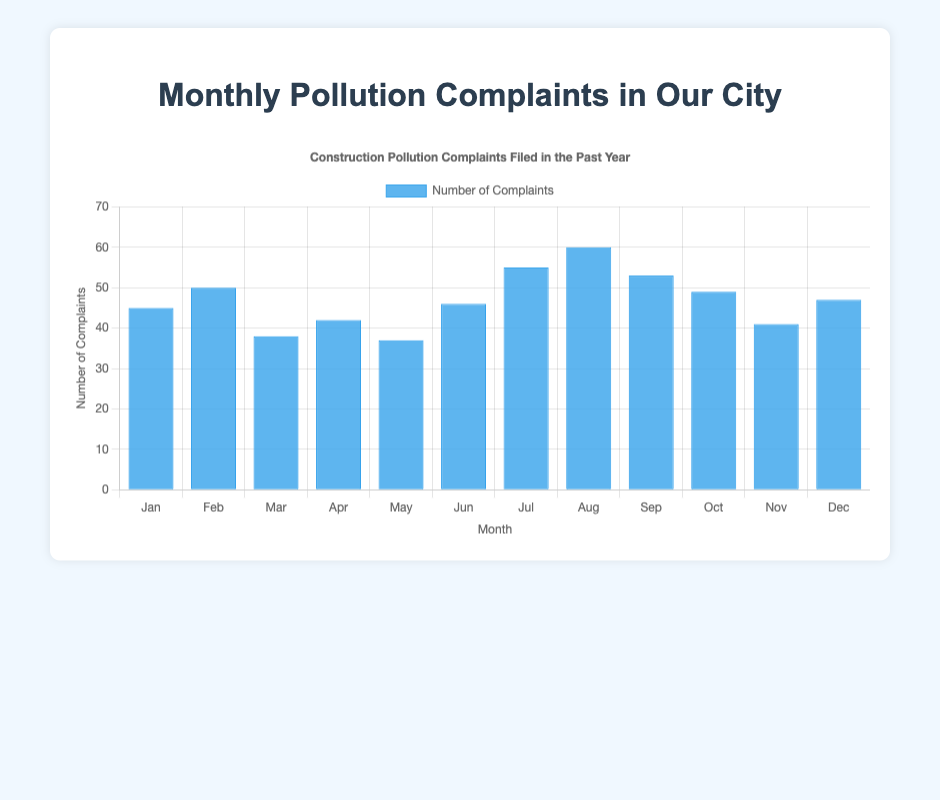Which month had the highest number of pollution complaints? By looking at the heights of the bars, note that August has the tallest blue bar, indicating the highest number of complaints at 60.
Answer: August Which month had the fewest pollution complaints? The month with the shortest blue bar represents the fewest complaints. By examining the chart, May has the shortest bar with 37 complaints.
Answer: May What is the average number of complaints filed per month? Sum the number of complaints for each month and then divide by the number of months. (45 + 50 + 38 + 42 + 37 + 46 + 55 + 60 + 53 + 49 + 41 + 47) = 563, then divide by 12. So the average is 563/12 ≈ 46.92.
Answer: 46.92 How many more complaints were filed in August than in January? Subtract the number of complaints in January from those in August. August has 60 complaints, and January has 45. Therefore, 60 - 45 = 15.
Answer: 15 Which months had more than 50 complaints? Identify bars taller than the line indicating 50 complaints. The months with more than 50 complaints are July (55), August (60), and September (53).
Answer: July, August, September In which month did complaints increase the most compared to the previous month? Calculate the difference between consecutive months to find the largest increase. The most significant increase is July over June, with a difference of 55 - 46 = 9.
Answer: July What was the total number of complaints for October and November combined? Add the complaints for October and November together: 49 (October) + 41 (November) = 90.
Answer: 90 Which month(s) had exactly 42 complaints? By visually identifying the bar with a height representing 42 complaints, April is the month that fits this criterion.
Answer: April How many complaints were filed in the second half of the year (July to December)? Sum the complaints for each month from July to December. (55 + 60 + 53 + 49 + 41 + 47) = 305.
Answer: 305 In which month did the number of complaints decrease compared to the previous month and by how much? Check for months where the bar height is smaller than the previous month and calculate the difference. From February to March, the complaints decreased from 50 to 38, a difference of 50 - 38 = 12.
Answer: March, 12 